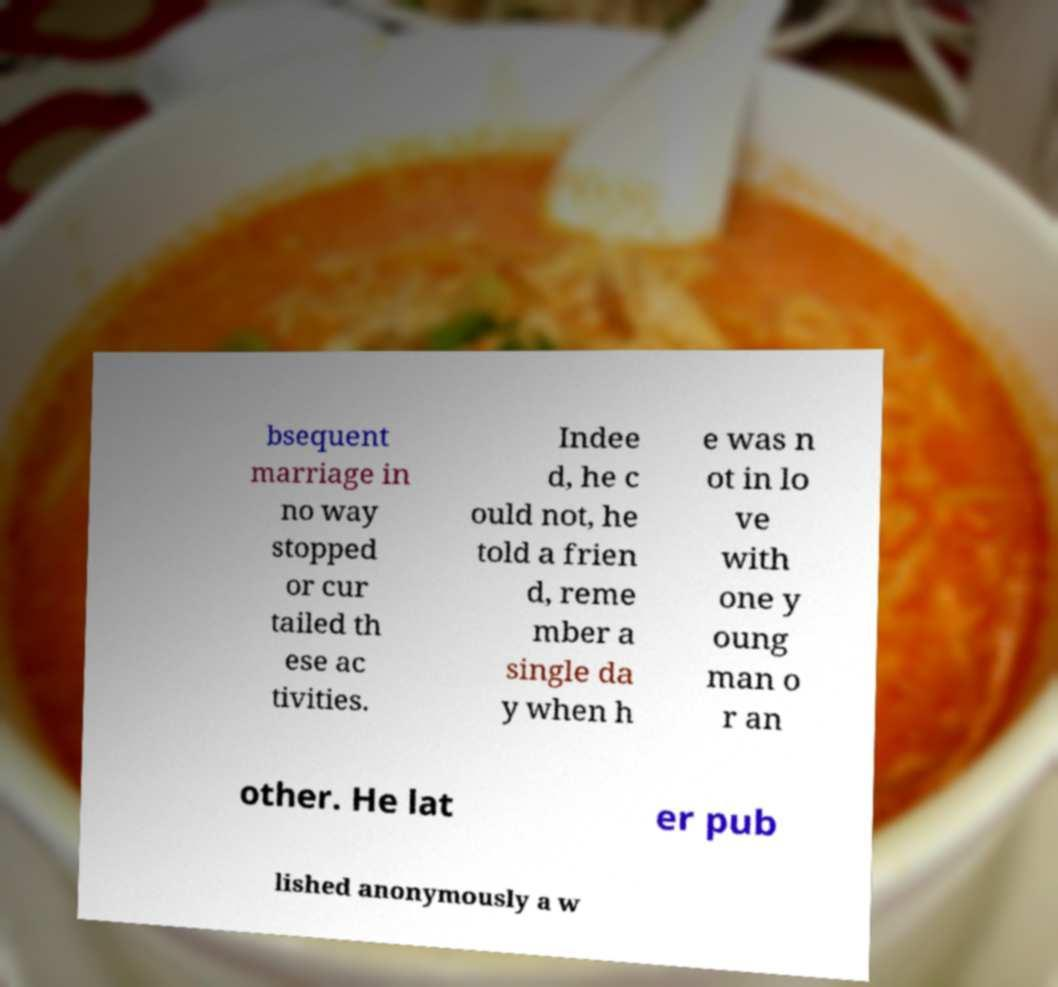Please identify and transcribe the text found in this image. bsequent marriage in no way stopped or cur tailed th ese ac tivities. Indee d, he c ould not, he told a frien d, reme mber a single da y when h e was n ot in lo ve with one y oung man o r an other. He lat er pub lished anonymously a w 